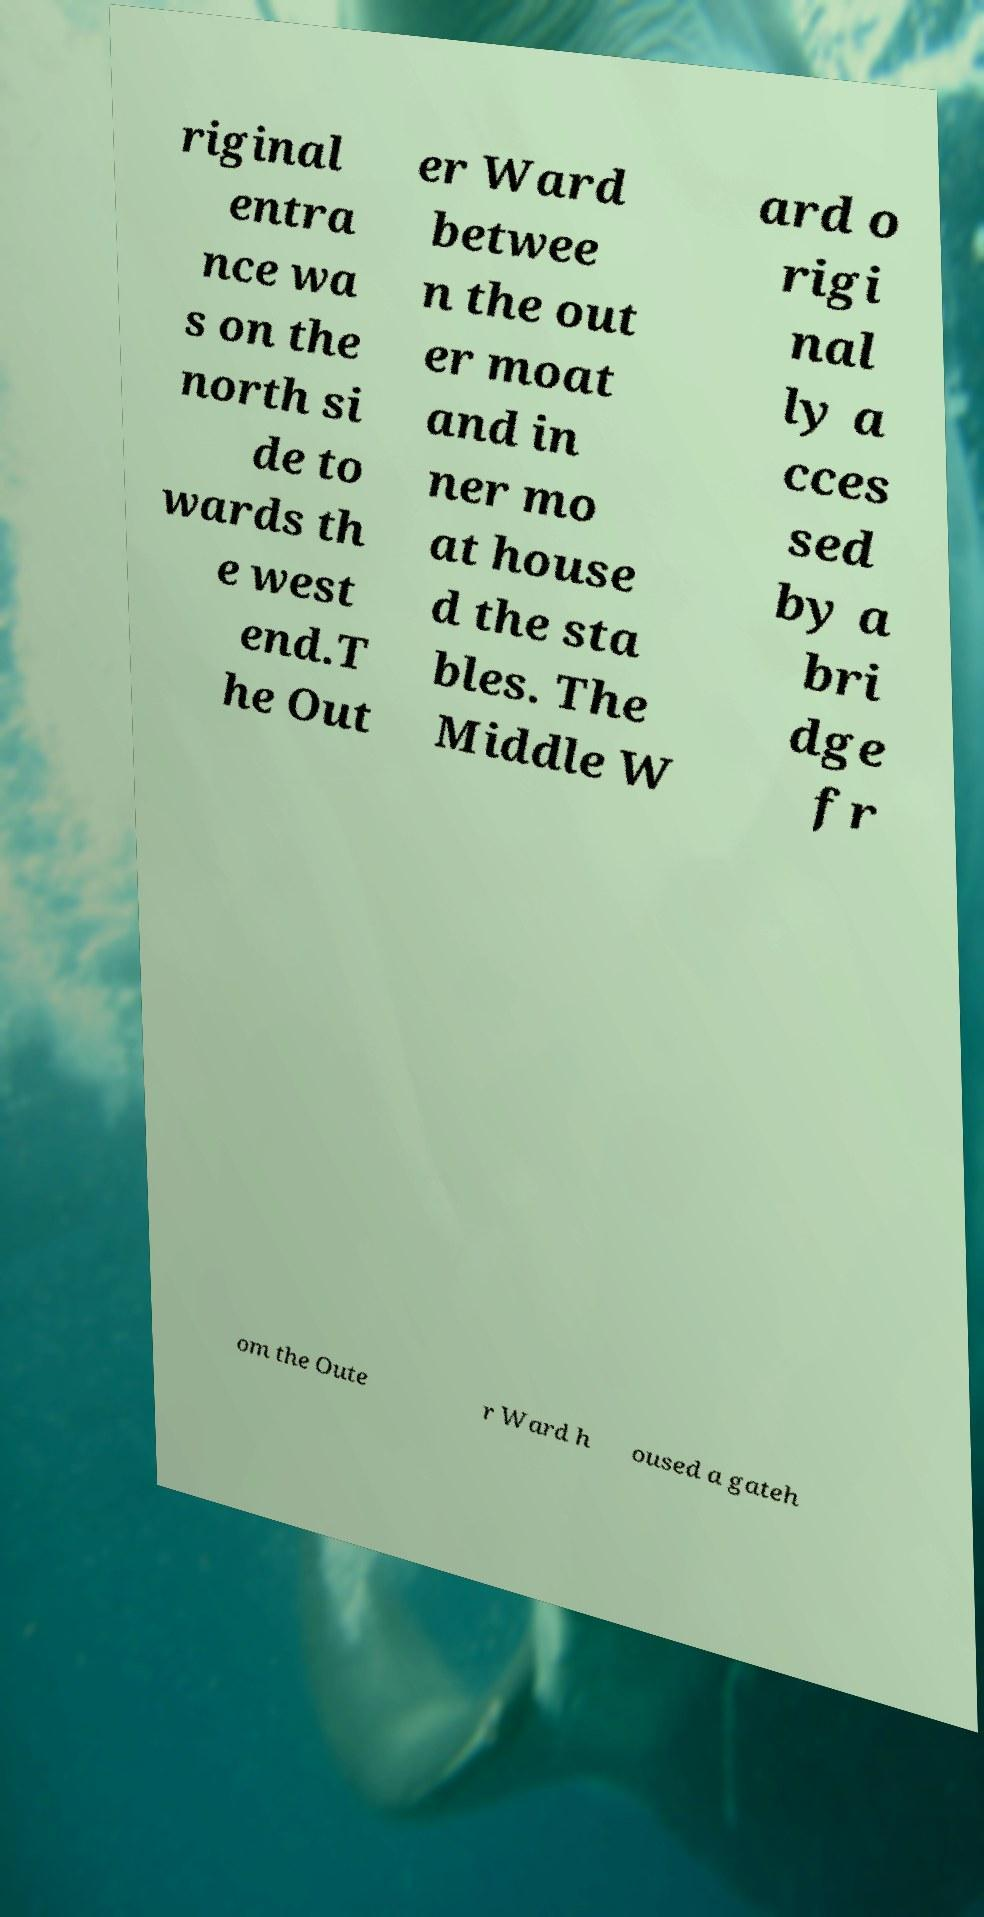Can you accurately transcribe the text from the provided image for me? riginal entra nce wa s on the north si de to wards th e west end.T he Out er Ward betwee n the out er moat and in ner mo at house d the sta bles. The Middle W ard o rigi nal ly a cces sed by a bri dge fr om the Oute r Ward h oused a gateh 